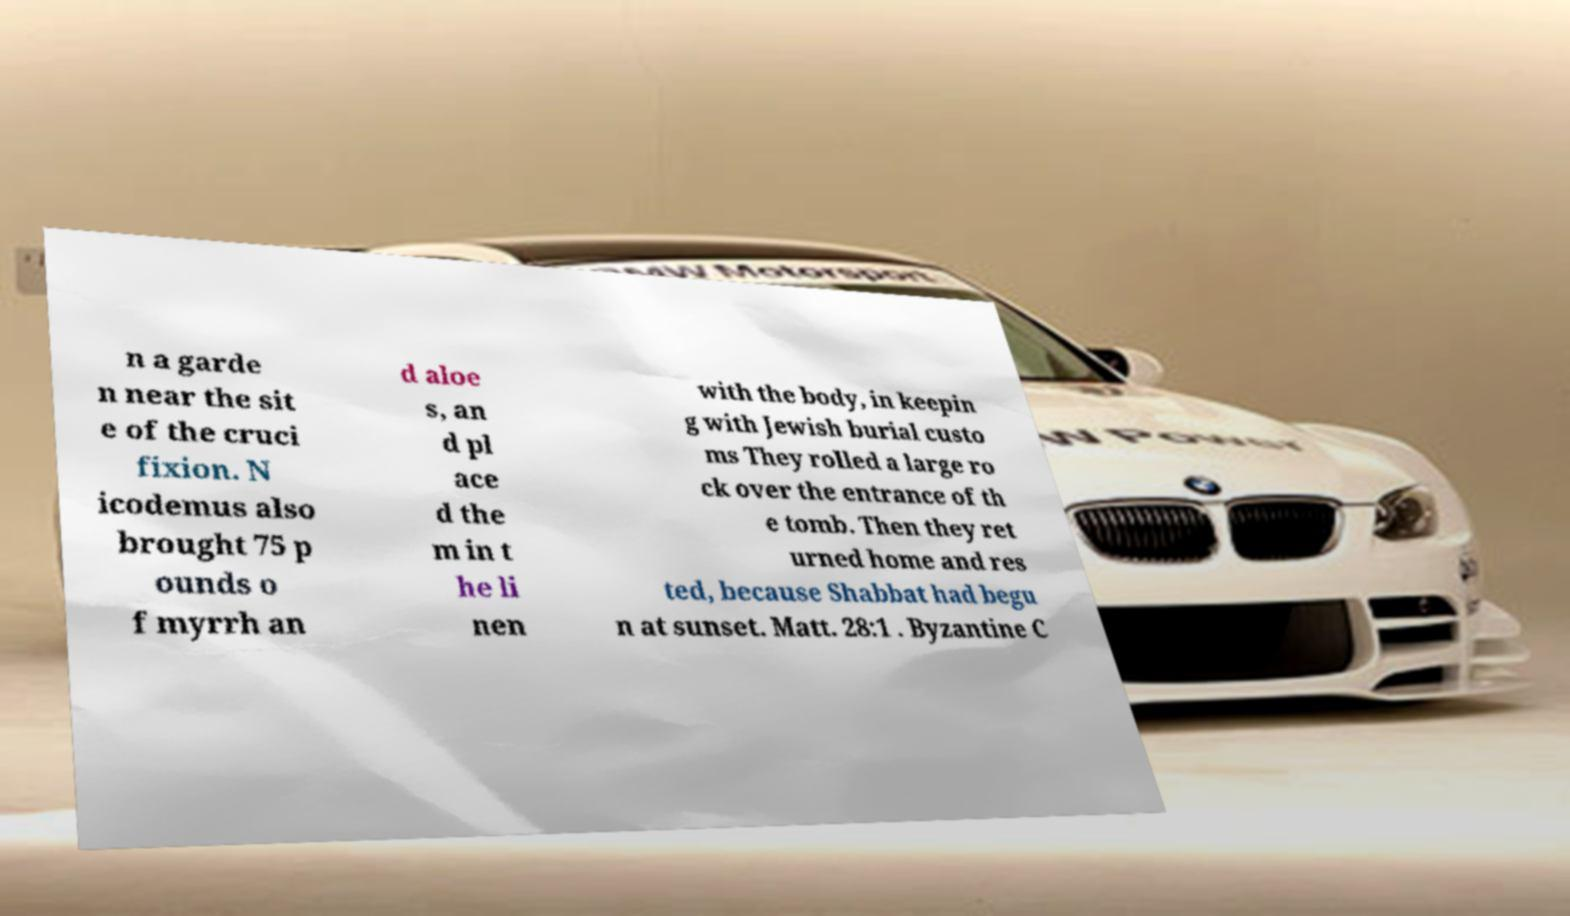Can you read and provide the text displayed in the image?This photo seems to have some interesting text. Can you extract and type it out for me? n a garde n near the sit e of the cruci fixion. N icodemus also brought 75 p ounds o f myrrh an d aloe s, an d pl ace d the m in t he li nen with the body, in keepin g with Jewish burial custo ms They rolled a large ro ck over the entrance of th e tomb. Then they ret urned home and res ted, because Shabbat had begu n at sunset. Matt. 28:1 . Byzantine C 